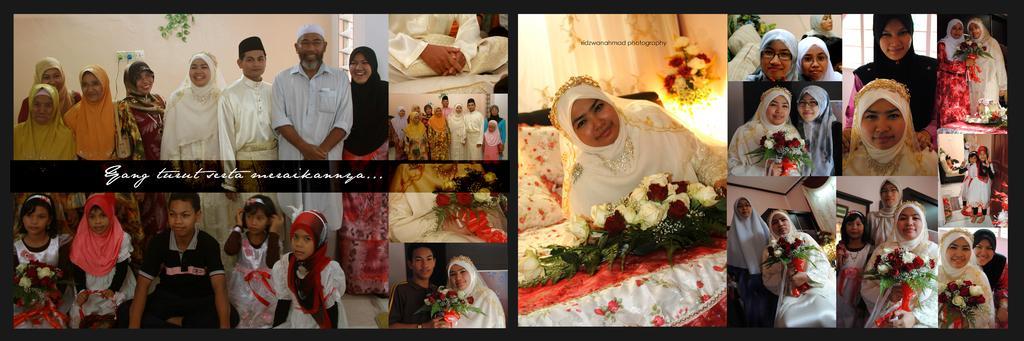Could you give a brief overview of what you see in this image? This is a collage image and here we can see people wearing kurtas and burkas and caps and we can see flower bouquets, some cloths, plants and there is a wall and we can see a bed. 